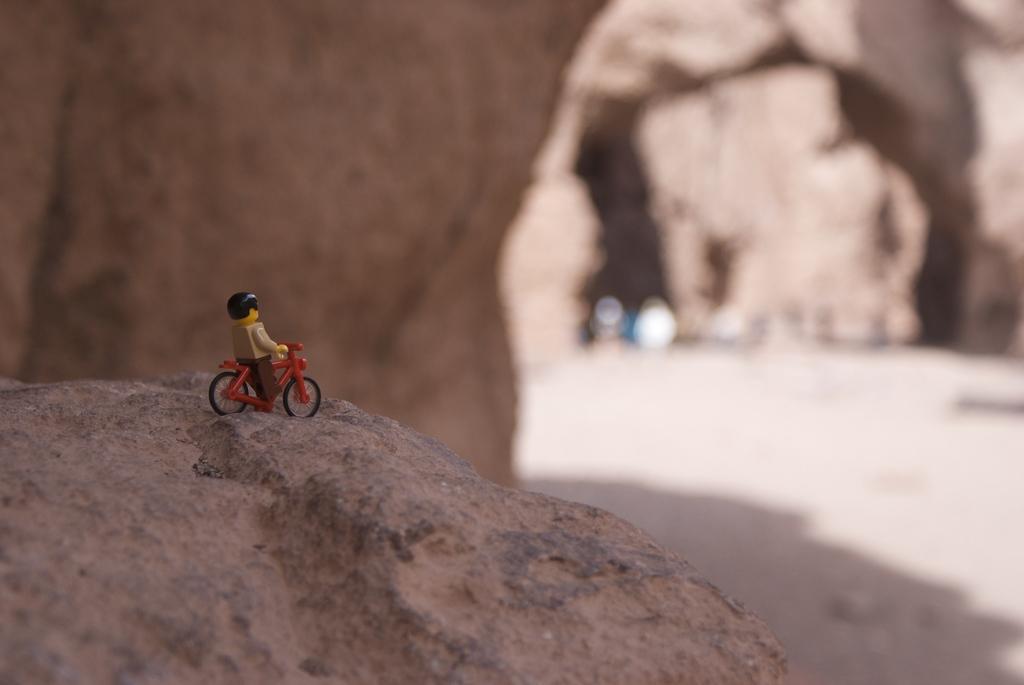Can you describe this image briefly? In this picture we can see a toy on a rock. There are few rocks in the background. 